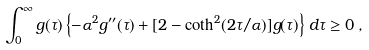Convert formula to latex. <formula><loc_0><loc_0><loc_500><loc_500>\int _ { 0 } ^ { \infty } g ( \tau ) \left \{ - \alpha ^ { 2 } g ^ { \prime \prime } ( \tau ) + [ 2 - \coth ^ { 2 } ( 2 \tau / \alpha ) ] g ( \tau ) \right \} \, d \tau \geq 0 \, ,</formula> 